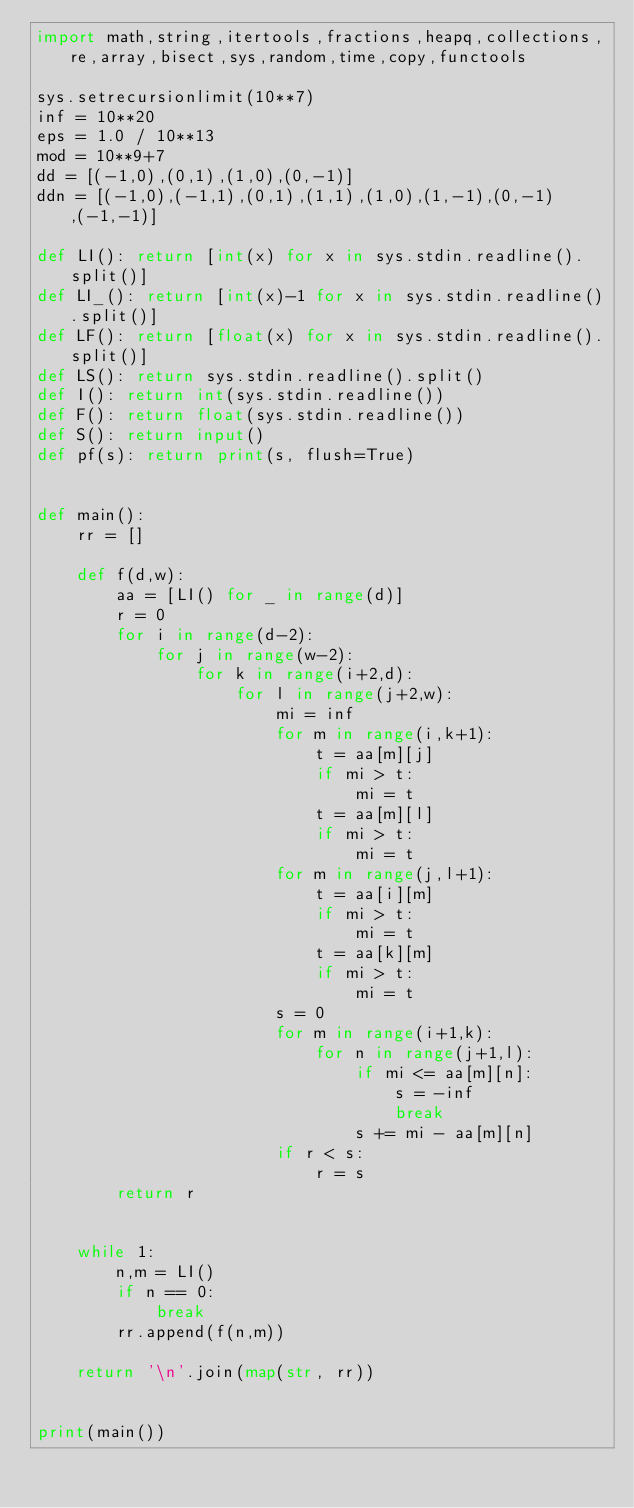Convert code to text. <code><loc_0><loc_0><loc_500><loc_500><_Python_>import math,string,itertools,fractions,heapq,collections,re,array,bisect,sys,random,time,copy,functools

sys.setrecursionlimit(10**7)
inf = 10**20
eps = 1.0 / 10**13
mod = 10**9+7
dd = [(-1,0),(0,1),(1,0),(0,-1)]
ddn = [(-1,0),(-1,1),(0,1),(1,1),(1,0),(1,-1),(0,-1),(-1,-1)]

def LI(): return [int(x) for x in sys.stdin.readline().split()]
def LI_(): return [int(x)-1 for x in sys.stdin.readline().split()]
def LF(): return [float(x) for x in sys.stdin.readline().split()]
def LS(): return sys.stdin.readline().split()
def I(): return int(sys.stdin.readline())
def F(): return float(sys.stdin.readline())
def S(): return input()
def pf(s): return print(s, flush=True)


def main():
    rr = []

    def f(d,w):
        aa = [LI() for _ in range(d)]
        r = 0
        for i in range(d-2):
            for j in range(w-2):
                for k in range(i+2,d):
                    for l in range(j+2,w):
                        mi = inf
                        for m in range(i,k+1):
                            t = aa[m][j]
                            if mi > t:
                                mi = t
                            t = aa[m][l]
                            if mi > t:
                                mi = t
                        for m in range(j,l+1):
                            t = aa[i][m]
                            if mi > t:
                                mi = t
                            t = aa[k][m]
                            if mi > t:
                                mi = t
                        s = 0
                        for m in range(i+1,k):
                            for n in range(j+1,l):
                                if mi <= aa[m][n]:
                                    s = -inf
                                    break
                                s += mi - aa[m][n]
                        if r < s:
                            r = s
        return r


    while 1:
        n,m = LI()
        if n == 0:
            break
        rr.append(f(n,m))

    return '\n'.join(map(str, rr))


print(main())

</code> 